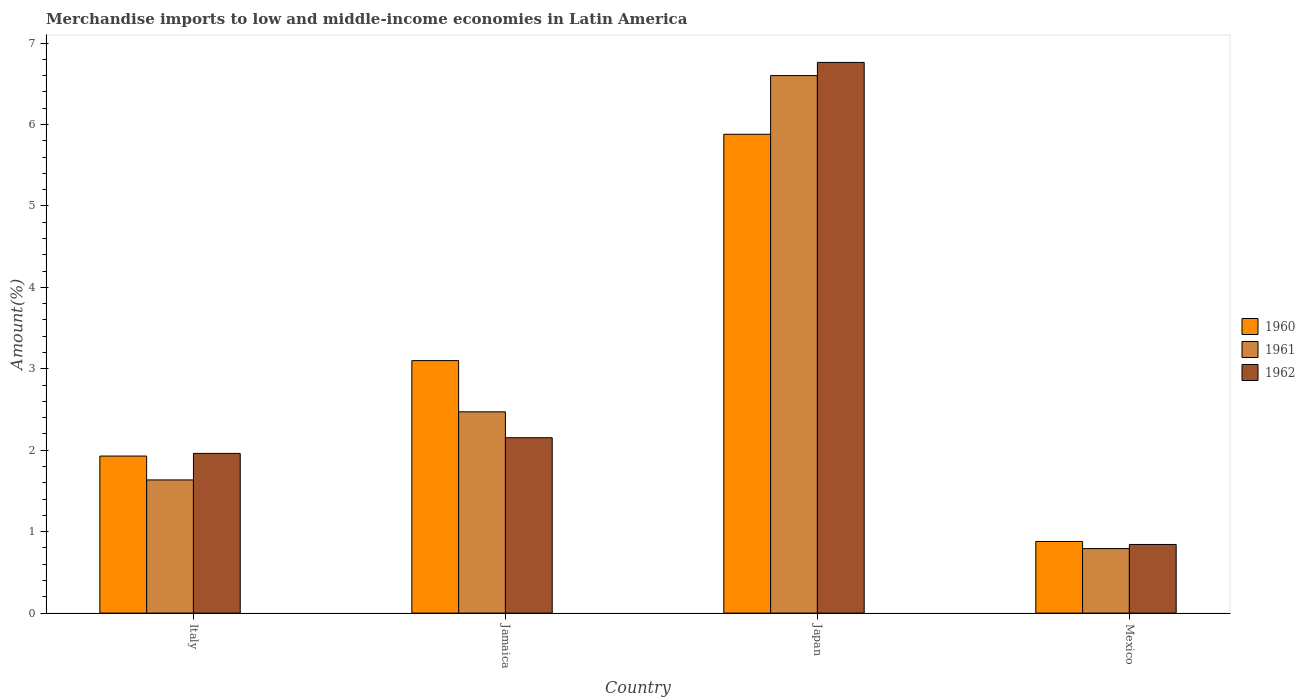How many different coloured bars are there?
Your answer should be very brief. 3. How many groups of bars are there?
Keep it short and to the point. 4. Are the number of bars on each tick of the X-axis equal?
Keep it short and to the point. Yes. In how many cases, is the number of bars for a given country not equal to the number of legend labels?
Your response must be concise. 0. What is the percentage of amount earned from merchandise imports in 1960 in Jamaica?
Give a very brief answer. 3.1. Across all countries, what is the maximum percentage of amount earned from merchandise imports in 1961?
Make the answer very short. 6.6. Across all countries, what is the minimum percentage of amount earned from merchandise imports in 1962?
Give a very brief answer. 0.84. In which country was the percentage of amount earned from merchandise imports in 1960 minimum?
Your response must be concise. Mexico. What is the total percentage of amount earned from merchandise imports in 1960 in the graph?
Give a very brief answer. 11.79. What is the difference between the percentage of amount earned from merchandise imports in 1961 in Italy and that in Japan?
Your answer should be compact. -4.97. What is the difference between the percentage of amount earned from merchandise imports in 1961 in Jamaica and the percentage of amount earned from merchandise imports in 1962 in Japan?
Keep it short and to the point. -4.29. What is the average percentage of amount earned from merchandise imports in 1962 per country?
Provide a succinct answer. 2.93. What is the difference between the percentage of amount earned from merchandise imports of/in 1960 and percentage of amount earned from merchandise imports of/in 1961 in Jamaica?
Your answer should be very brief. 0.63. In how many countries, is the percentage of amount earned from merchandise imports in 1961 greater than 0.4 %?
Keep it short and to the point. 4. What is the ratio of the percentage of amount earned from merchandise imports in 1960 in Italy to that in Jamaica?
Make the answer very short. 0.62. What is the difference between the highest and the second highest percentage of amount earned from merchandise imports in 1961?
Your response must be concise. -0.84. What is the difference between the highest and the lowest percentage of amount earned from merchandise imports in 1962?
Provide a succinct answer. 5.92. In how many countries, is the percentage of amount earned from merchandise imports in 1960 greater than the average percentage of amount earned from merchandise imports in 1960 taken over all countries?
Offer a terse response. 2. What does the 2nd bar from the left in Japan represents?
Provide a short and direct response. 1961. Is it the case that in every country, the sum of the percentage of amount earned from merchandise imports in 1960 and percentage of amount earned from merchandise imports in 1962 is greater than the percentage of amount earned from merchandise imports in 1961?
Provide a short and direct response. Yes. Are all the bars in the graph horizontal?
Your answer should be very brief. No. How many countries are there in the graph?
Offer a terse response. 4. Does the graph contain any zero values?
Your answer should be compact. No. Where does the legend appear in the graph?
Your response must be concise. Center right. What is the title of the graph?
Offer a terse response. Merchandise imports to low and middle-income economies in Latin America. Does "1991" appear as one of the legend labels in the graph?
Provide a succinct answer. No. What is the label or title of the Y-axis?
Offer a terse response. Amount(%). What is the Amount(%) of 1960 in Italy?
Make the answer very short. 1.93. What is the Amount(%) in 1961 in Italy?
Provide a short and direct response. 1.64. What is the Amount(%) in 1962 in Italy?
Your answer should be very brief. 1.96. What is the Amount(%) of 1960 in Jamaica?
Provide a succinct answer. 3.1. What is the Amount(%) in 1961 in Jamaica?
Give a very brief answer. 2.47. What is the Amount(%) of 1962 in Jamaica?
Provide a succinct answer. 2.15. What is the Amount(%) of 1960 in Japan?
Your answer should be compact. 5.88. What is the Amount(%) in 1961 in Japan?
Provide a short and direct response. 6.6. What is the Amount(%) of 1962 in Japan?
Your response must be concise. 6.76. What is the Amount(%) in 1960 in Mexico?
Your answer should be compact. 0.88. What is the Amount(%) in 1961 in Mexico?
Offer a terse response. 0.79. What is the Amount(%) in 1962 in Mexico?
Your response must be concise. 0.84. Across all countries, what is the maximum Amount(%) in 1960?
Provide a succinct answer. 5.88. Across all countries, what is the maximum Amount(%) of 1961?
Keep it short and to the point. 6.6. Across all countries, what is the maximum Amount(%) of 1962?
Make the answer very short. 6.76. Across all countries, what is the minimum Amount(%) of 1960?
Provide a succinct answer. 0.88. Across all countries, what is the minimum Amount(%) in 1961?
Provide a short and direct response. 0.79. Across all countries, what is the minimum Amount(%) in 1962?
Offer a very short reply. 0.84. What is the total Amount(%) of 1960 in the graph?
Provide a succinct answer. 11.79. What is the total Amount(%) in 1961 in the graph?
Your answer should be compact. 11.5. What is the total Amount(%) in 1962 in the graph?
Offer a very short reply. 11.72. What is the difference between the Amount(%) of 1960 in Italy and that in Jamaica?
Ensure brevity in your answer.  -1.17. What is the difference between the Amount(%) of 1961 in Italy and that in Jamaica?
Offer a very short reply. -0.84. What is the difference between the Amount(%) in 1962 in Italy and that in Jamaica?
Offer a terse response. -0.19. What is the difference between the Amount(%) in 1960 in Italy and that in Japan?
Your response must be concise. -3.95. What is the difference between the Amount(%) in 1961 in Italy and that in Japan?
Ensure brevity in your answer.  -4.97. What is the difference between the Amount(%) in 1962 in Italy and that in Japan?
Give a very brief answer. -4.8. What is the difference between the Amount(%) of 1960 in Italy and that in Mexico?
Your answer should be very brief. 1.05. What is the difference between the Amount(%) of 1961 in Italy and that in Mexico?
Offer a terse response. 0.84. What is the difference between the Amount(%) in 1962 in Italy and that in Mexico?
Ensure brevity in your answer.  1.12. What is the difference between the Amount(%) of 1960 in Jamaica and that in Japan?
Provide a succinct answer. -2.78. What is the difference between the Amount(%) of 1961 in Jamaica and that in Japan?
Keep it short and to the point. -4.13. What is the difference between the Amount(%) of 1962 in Jamaica and that in Japan?
Offer a terse response. -4.61. What is the difference between the Amount(%) in 1960 in Jamaica and that in Mexico?
Ensure brevity in your answer.  2.22. What is the difference between the Amount(%) of 1961 in Jamaica and that in Mexico?
Give a very brief answer. 1.68. What is the difference between the Amount(%) of 1962 in Jamaica and that in Mexico?
Your response must be concise. 1.31. What is the difference between the Amount(%) in 1960 in Japan and that in Mexico?
Give a very brief answer. 5. What is the difference between the Amount(%) of 1961 in Japan and that in Mexico?
Your answer should be very brief. 5.81. What is the difference between the Amount(%) of 1962 in Japan and that in Mexico?
Provide a succinct answer. 5.92. What is the difference between the Amount(%) in 1960 in Italy and the Amount(%) in 1961 in Jamaica?
Your answer should be compact. -0.54. What is the difference between the Amount(%) in 1960 in Italy and the Amount(%) in 1962 in Jamaica?
Ensure brevity in your answer.  -0.23. What is the difference between the Amount(%) of 1961 in Italy and the Amount(%) of 1962 in Jamaica?
Offer a very short reply. -0.52. What is the difference between the Amount(%) of 1960 in Italy and the Amount(%) of 1961 in Japan?
Offer a terse response. -4.67. What is the difference between the Amount(%) in 1960 in Italy and the Amount(%) in 1962 in Japan?
Your answer should be very brief. -4.83. What is the difference between the Amount(%) of 1961 in Italy and the Amount(%) of 1962 in Japan?
Your response must be concise. -5.13. What is the difference between the Amount(%) of 1960 in Italy and the Amount(%) of 1961 in Mexico?
Make the answer very short. 1.14. What is the difference between the Amount(%) in 1960 in Italy and the Amount(%) in 1962 in Mexico?
Provide a short and direct response. 1.09. What is the difference between the Amount(%) in 1961 in Italy and the Amount(%) in 1962 in Mexico?
Ensure brevity in your answer.  0.79. What is the difference between the Amount(%) in 1960 in Jamaica and the Amount(%) in 1961 in Japan?
Provide a short and direct response. -3.5. What is the difference between the Amount(%) of 1960 in Jamaica and the Amount(%) of 1962 in Japan?
Offer a terse response. -3.66. What is the difference between the Amount(%) in 1961 in Jamaica and the Amount(%) in 1962 in Japan?
Provide a short and direct response. -4.29. What is the difference between the Amount(%) of 1960 in Jamaica and the Amount(%) of 1961 in Mexico?
Provide a succinct answer. 2.31. What is the difference between the Amount(%) in 1960 in Jamaica and the Amount(%) in 1962 in Mexico?
Make the answer very short. 2.26. What is the difference between the Amount(%) of 1961 in Jamaica and the Amount(%) of 1962 in Mexico?
Your answer should be compact. 1.63. What is the difference between the Amount(%) in 1960 in Japan and the Amount(%) in 1961 in Mexico?
Ensure brevity in your answer.  5.09. What is the difference between the Amount(%) in 1960 in Japan and the Amount(%) in 1962 in Mexico?
Make the answer very short. 5.04. What is the difference between the Amount(%) of 1961 in Japan and the Amount(%) of 1962 in Mexico?
Provide a succinct answer. 5.76. What is the average Amount(%) in 1960 per country?
Make the answer very short. 2.95. What is the average Amount(%) in 1961 per country?
Ensure brevity in your answer.  2.87. What is the average Amount(%) of 1962 per country?
Your response must be concise. 2.93. What is the difference between the Amount(%) of 1960 and Amount(%) of 1961 in Italy?
Give a very brief answer. 0.29. What is the difference between the Amount(%) in 1960 and Amount(%) in 1962 in Italy?
Ensure brevity in your answer.  -0.03. What is the difference between the Amount(%) of 1961 and Amount(%) of 1962 in Italy?
Your answer should be compact. -0.33. What is the difference between the Amount(%) in 1960 and Amount(%) in 1961 in Jamaica?
Provide a succinct answer. 0.63. What is the difference between the Amount(%) of 1960 and Amount(%) of 1962 in Jamaica?
Provide a succinct answer. 0.95. What is the difference between the Amount(%) in 1961 and Amount(%) in 1962 in Jamaica?
Offer a terse response. 0.32. What is the difference between the Amount(%) of 1960 and Amount(%) of 1961 in Japan?
Offer a terse response. -0.72. What is the difference between the Amount(%) of 1960 and Amount(%) of 1962 in Japan?
Provide a succinct answer. -0.88. What is the difference between the Amount(%) of 1961 and Amount(%) of 1962 in Japan?
Offer a very short reply. -0.16. What is the difference between the Amount(%) in 1960 and Amount(%) in 1961 in Mexico?
Provide a short and direct response. 0.09. What is the difference between the Amount(%) of 1960 and Amount(%) of 1962 in Mexico?
Provide a short and direct response. 0.04. What is the difference between the Amount(%) of 1961 and Amount(%) of 1962 in Mexico?
Offer a very short reply. -0.05. What is the ratio of the Amount(%) in 1960 in Italy to that in Jamaica?
Offer a terse response. 0.62. What is the ratio of the Amount(%) of 1961 in Italy to that in Jamaica?
Ensure brevity in your answer.  0.66. What is the ratio of the Amount(%) in 1962 in Italy to that in Jamaica?
Make the answer very short. 0.91. What is the ratio of the Amount(%) in 1960 in Italy to that in Japan?
Offer a terse response. 0.33. What is the ratio of the Amount(%) of 1961 in Italy to that in Japan?
Your response must be concise. 0.25. What is the ratio of the Amount(%) of 1962 in Italy to that in Japan?
Offer a very short reply. 0.29. What is the ratio of the Amount(%) of 1960 in Italy to that in Mexico?
Offer a very short reply. 2.19. What is the ratio of the Amount(%) of 1961 in Italy to that in Mexico?
Provide a succinct answer. 2.06. What is the ratio of the Amount(%) in 1962 in Italy to that in Mexico?
Ensure brevity in your answer.  2.33. What is the ratio of the Amount(%) of 1960 in Jamaica to that in Japan?
Your answer should be compact. 0.53. What is the ratio of the Amount(%) of 1961 in Jamaica to that in Japan?
Offer a very short reply. 0.37. What is the ratio of the Amount(%) in 1962 in Jamaica to that in Japan?
Your answer should be compact. 0.32. What is the ratio of the Amount(%) in 1960 in Jamaica to that in Mexico?
Provide a short and direct response. 3.53. What is the ratio of the Amount(%) of 1961 in Jamaica to that in Mexico?
Make the answer very short. 3.12. What is the ratio of the Amount(%) of 1962 in Jamaica to that in Mexico?
Give a very brief answer. 2.56. What is the ratio of the Amount(%) in 1960 in Japan to that in Mexico?
Your answer should be compact. 6.69. What is the ratio of the Amount(%) of 1961 in Japan to that in Mexico?
Offer a very short reply. 8.33. What is the ratio of the Amount(%) of 1962 in Japan to that in Mexico?
Offer a very short reply. 8.02. What is the difference between the highest and the second highest Amount(%) of 1960?
Ensure brevity in your answer.  2.78. What is the difference between the highest and the second highest Amount(%) of 1961?
Your answer should be compact. 4.13. What is the difference between the highest and the second highest Amount(%) in 1962?
Your answer should be compact. 4.61. What is the difference between the highest and the lowest Amount(%) in 1960?
Provide a short and direct response. 5. What is the difference between the highest and the lowest Amount(%) in 1961?
Provide a succinct answer. 5.81. What is the difference between the highest and the lowest Amount(%) of 1962?
Provide a short and direct response. 5.92. 